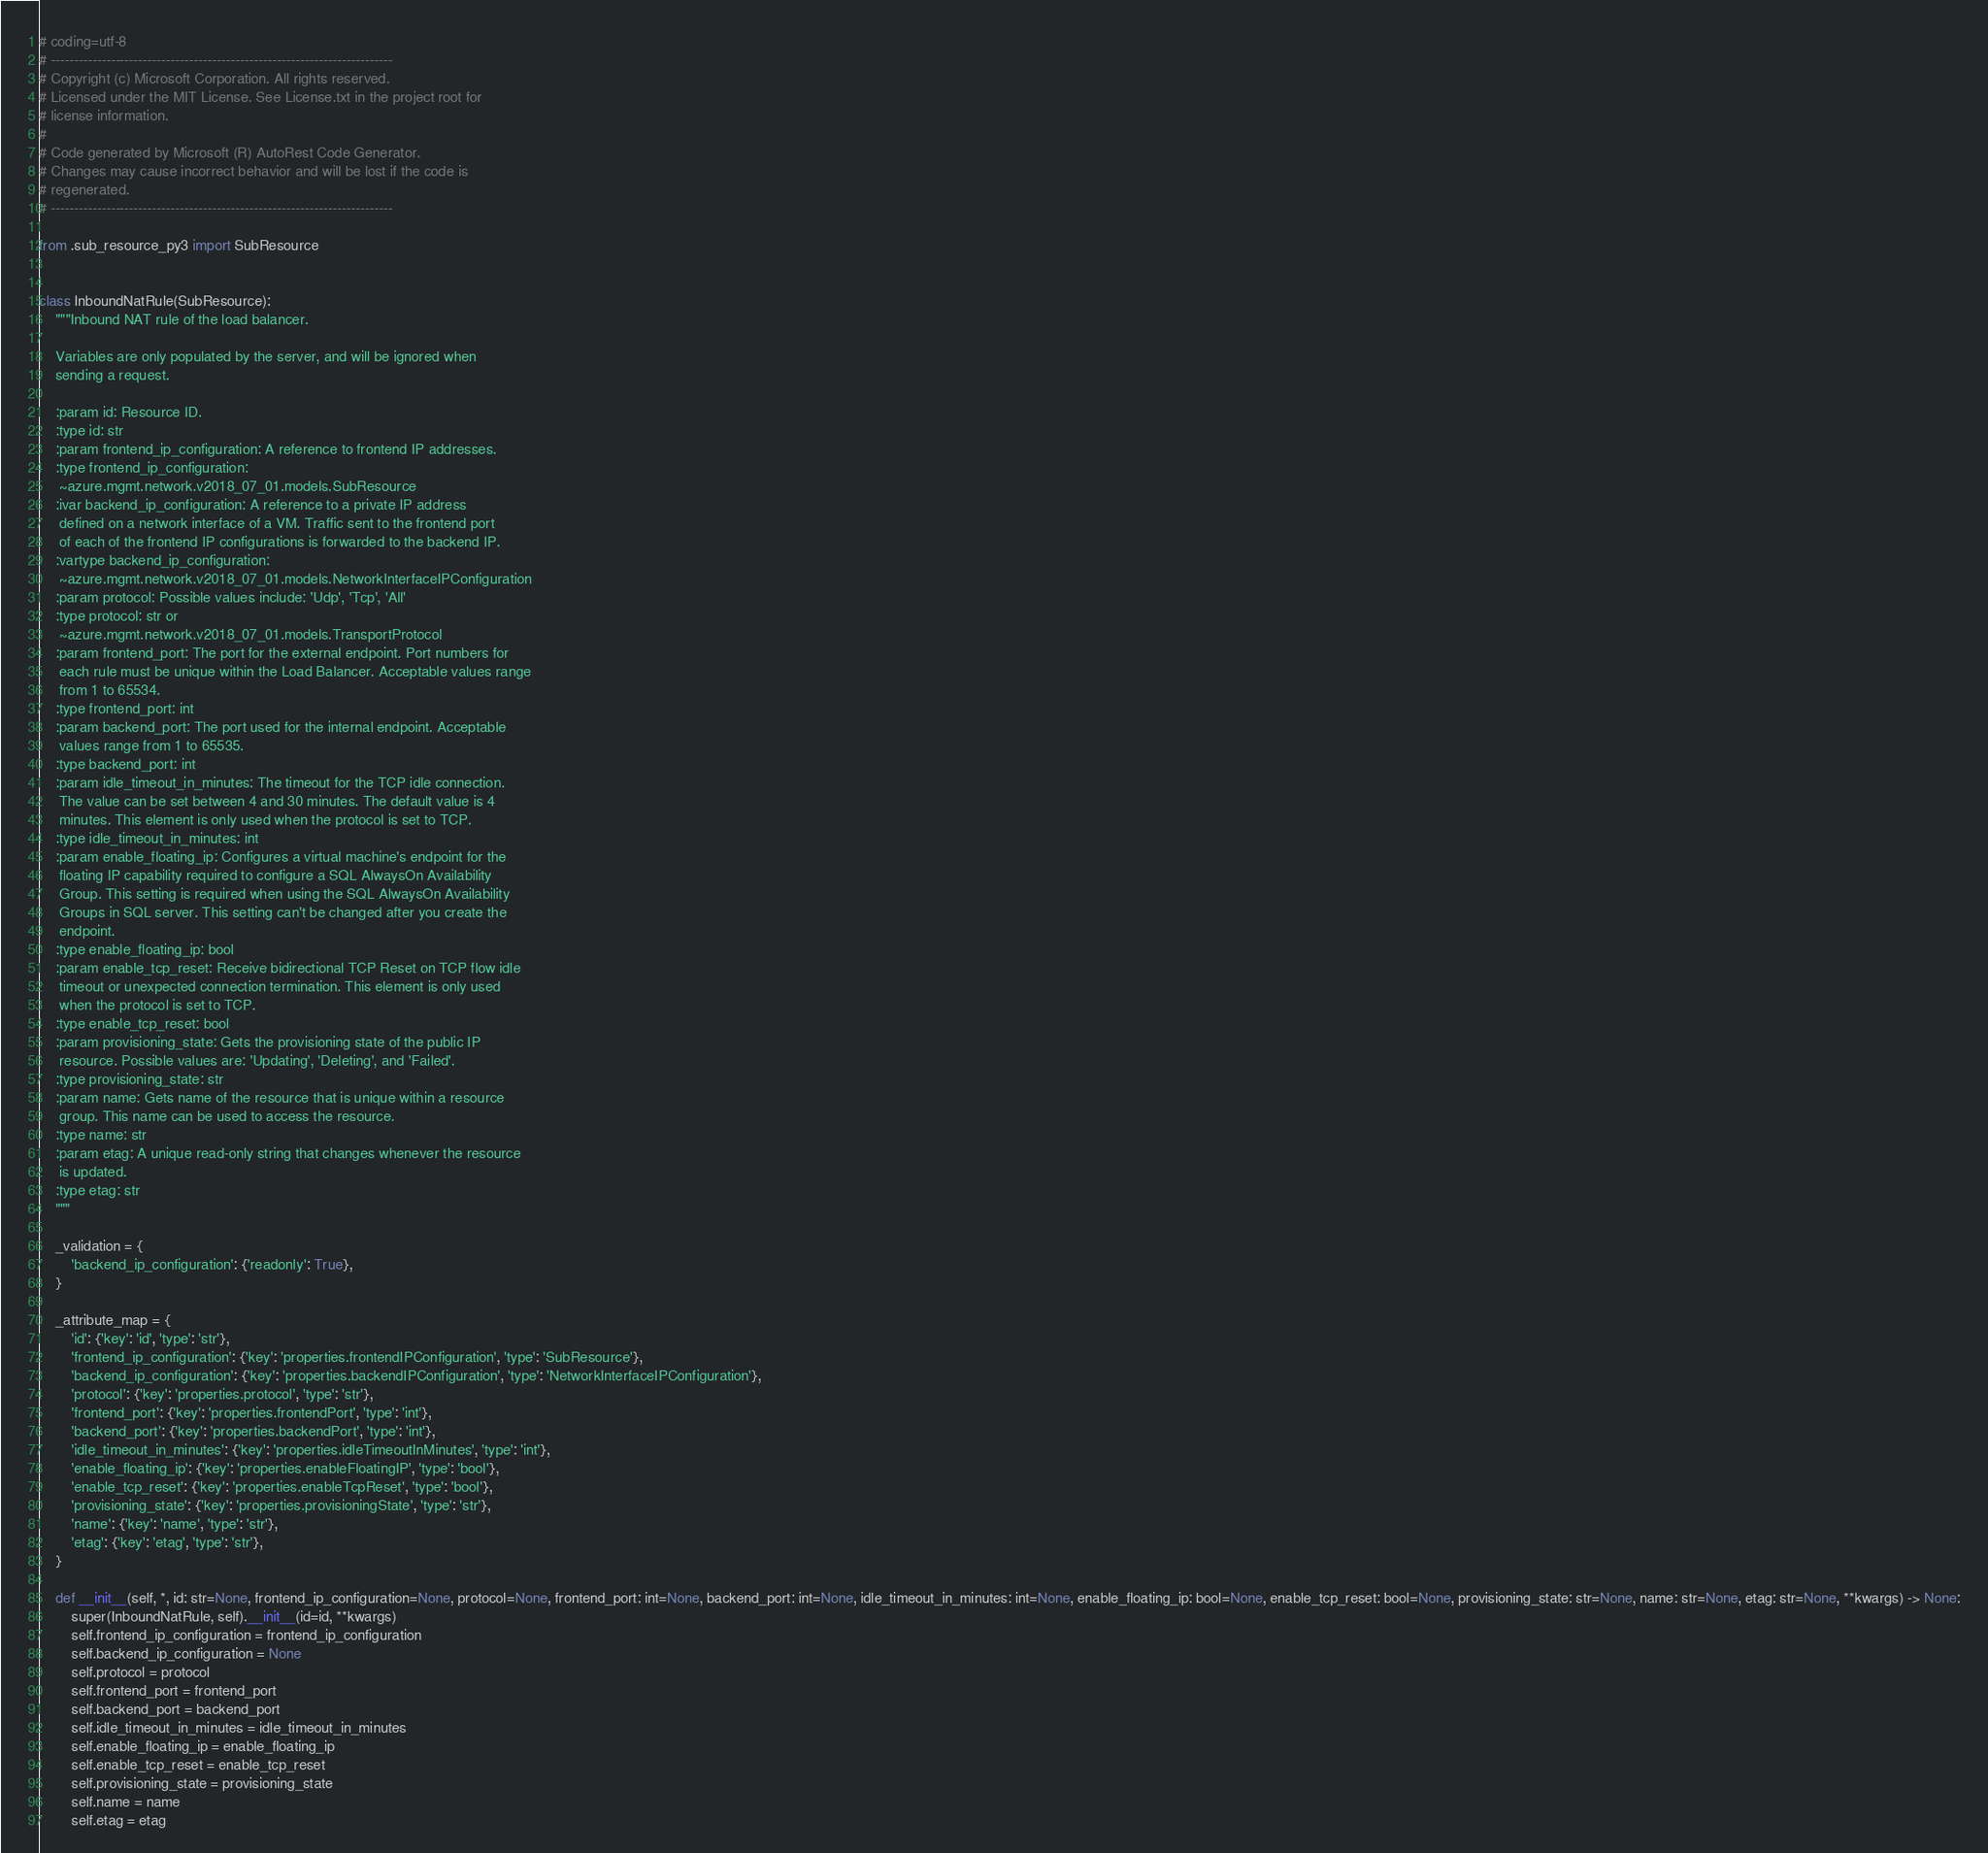Convert code to text. <code><loc_0><loc_0><loc_500><loc_500><_Python_># coding=utf-8
# --------------------------------------------------------------------------
# Copyright (c) Microsoft Corporation. All rights reserved.
# Licensed under the MIT License. See License.txt in the project root for
# license information.
#
# Code generated by Microsoft (R) AutoRest Code Generator.
# Changes may cause incorrect behavior and will be lost if the code is
# regenerated.
# --------------------------------------------------------------------------

from .sub_resource_py3 import SubResource


class InboundNatRule(SubResource):
    """Inbound NAT rule of the load balancer.

    Variables are only populated by the server, and will be ignored when
    sending a request.

    :param id: Resource ID.
    :type id: str
    :param frontend_ip_configuration: A reference to frontend IP addresses.
    :type frontend_ip_configuration:
     ~azure.mgmt.network.v2018_07_01.models.SubResource
    :ivar backend_ip_configuration: A reference to a private IP address
     defined on a network interface of a VM. Traffic sent to the frontend port
     of each of the frontend IP configurations is forwarded to the backend IP.
    :vartype backend_ip_configuration:
     ~azure.mgmt.network.v2018_07_01.models.NetworkInterfaceIPConfiguration
    :param protocol: Possible values include: 'Udp', 'Tcp', 'All'
    :type protocol: str or
     ~azure.mgmt.network.v2018_07_01.models.TransportProtocol
    :param frontend_port: The port for the external endpoint. Port numbers for
     each rule must be unique within the Load Balancer. Acceptable values range
     from 1 to 65534.
    :type frontend_port: int
    :param backend_port: The port used for the internal endpoint. Acceptable
     values range from 1 to 65535.
    :type backend_port: int
    :param idle_timeout_in_minutes: The timeout for the TCP idle connection.
     The value can be set between 4 and 30 minutes. The default value is 4
     minutes. This element is only used when the protocol is set to TCP.
    :type idle_timeout_in_minutes: int
    :param enable_floating_ip: Configures a virtual machine's endpoint for the
     floating IP capability required to configure a SQL AlwaysOn Availability
     Group. This setting is required when using the SQL AlwaysOn Availability
     Groups in SQL server. This setting can't be changed after you create the
     endpoint.
    :type enable_floating_ip: bool
    :param enable_tcp_reset: Receive bidirectional TCP Reset on TCP flow idle
     timeout or unexpected connection termination. This element is only used
     when the protocol is set to TCP.
    :type enable_tcp_reset: bool
    :param provisioning_state: Gets the provisioning state of the public IP
     resource. Possible values are: 'Updating', 'Deleting', and 'Failed'.
    :type provisioning_state: str
    :param name: Gets name of the resource that is unique within a resource
     group. This name can be used to access the resource.
    :type name: str
    :param etag: A unique read-only string that changes whenever the resource
     is updated.
    :type etag: str
    """

    _validation = {
        'backend_ip_configuration': {'readonly': True},
    }

    _attribute_map = {
        'id': {'key': 'id', 'type': 'str'},
        'frontend_ip_configuration': {'key': 'properties.frontendIPConfiguration', 'type': 'SubResource'},
        'backend_ip_configuration': {'key': 'properties.backendIPConfiguration', 'type': 'NetworkInterfaceIPConfiguration'},
        'protocol': {'key': 'properties.protocol', 'type': 'str'},
        'frontend_port': {'key': 'properties.frontendPort', 'type': 'int'},
        'backend_port': {'key': 'properties.backendPort', 'type': 'int'},
        'idle_timeout_in_minutes': {'key': 'properties.idleTimeoutInMinutes', 'type': 'int'},
        'enable_floating_ip': {'key': 'properties.enableFloatingIP', 'type': 'bool'},
        'enable_tcp_reset': {'key': 'properties.enableTcpReset', 'type': 'bool'},
        'provisioning_state': {'key': 'properties.provisioningState', 'type': 'str'},
        'name': {'key': 'name', 'type': 'str'},
        'etag': {'key': 'etag', 'type': 'str'},
    }

    def __init__(self, *, id: str=None, frontend_ip_configuration=None, protocol=None, frontend_port: int=None, backend_port: int=None, idle_timeout_in_minutes: int=None, enable_floating_ip: bool=None, enable_tcp_reset: bool=None, provisioning_state: str=None, name: str=None, etag: str=None, **kwargs) -> None:
        super(InboundNatRule, self).__init__(id=id, **kwargs)
        self.frontend_ip_configuration = frontend_ip_configuration
        self.backend_ip_configuration = None
        self.protocol = protocol
        self.frontend_port = frontend_port
        self.backend_port = backend_port
        self.idle_timeout_in_minutes = idle_timeout_in_minutes
        self.enable_floating_ip = enable_floating_ip
        self.enable_tcp_reset = enable_tcp_reset
        self.provisioning_state = provisioning_state
        self.name = name
        self.etag = etag
</code> 